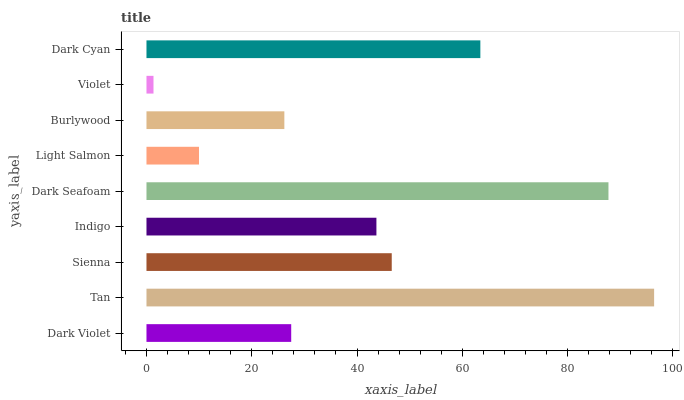Is Violet the minimum?
Answer yes or no. Yes. Is Tan the maximum?
Answer yes or no. Yes. Is Sienna the minimum?
Answer yes or no. No. Is Sienna the maximum?
Answer yes or no. No. Is Tan greater than Sienna?
Answer yes or no. Yes. Is Sienna less than Tan?
Answer yes or no. Yes. Is Sienna greater than Tan?
Answer yes or no. No. Is Tan less than Sienna?
Answer yes or no. No. Is Indigo the high median?
Answer yes or no. Yes. Is Indigo the low median?
Answer yes or no. Yes. Is Violet the high median?
Answer yes or no. No. Is Sienna the low median?
Answer yes or no. No. 